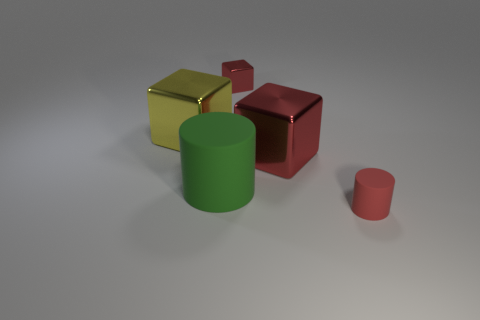Are any big cyan things visible?
Your answer should be compact. No. There is a tiny cube; is it the same color as the big metal thing that is right of the tiny red shiny block?
Your answer should be compact. Yes. The small metal thing has what color?
Offer a terse response. Red. What color is the other thing that is the same shape as the big green rubber object?
Keep it short and to the point. Red. Is the shape of the yellow object the same as the big green thing?
Offer a terse response. No. What number of cubes are either red objects or matte objects?
Make the answer very short. 2. There is a large block that is the same material as the large yellow object; what is its color?
Offer a very short reply. Red. There is a matte cylinder that is in front of the green matte cylinder; is it the same size as the yellow block?
Keep it short and to the point. No. Do the tiny red cube and the big cube left of the green thing have the same material?
Provide a short and direct response. Yes. What is the color of the metallic block left of the tiny red block?
Offer a terse response. Yellow. 